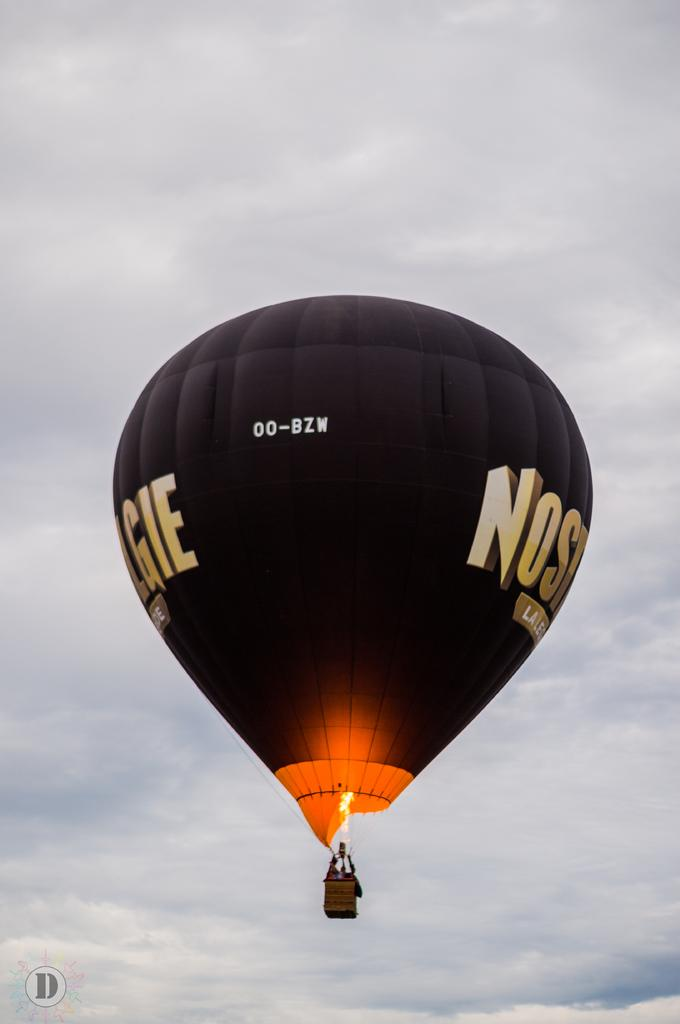<image>
Relay a brief, clear account of the picture shown. A black hot air balloon with the numbers 00-BZW on its side. 